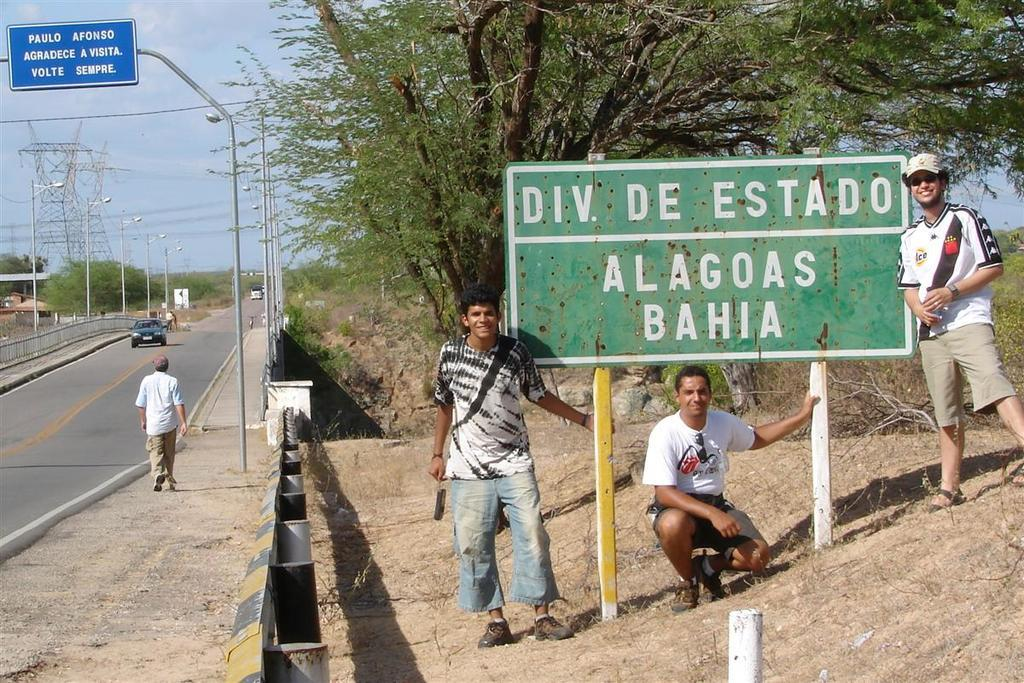What can be seen on the right side of the image? There is a sign board on the right side of the image. What are the men in the image doing? The men in the image are standing and smiling. What type of natural vegetation is visible in the image? Trees are visible in the image. What is the man on the left side of the image doing? A man is walking on the footpath in the left side of the image. What type of path is visible in the image? There is a road in the image. What type of button can be seen on the cap of the man in the image? There is no cap or button present in the image. What scent is associated with the trees in the image? The image does not provide information about the scent of the trees. 